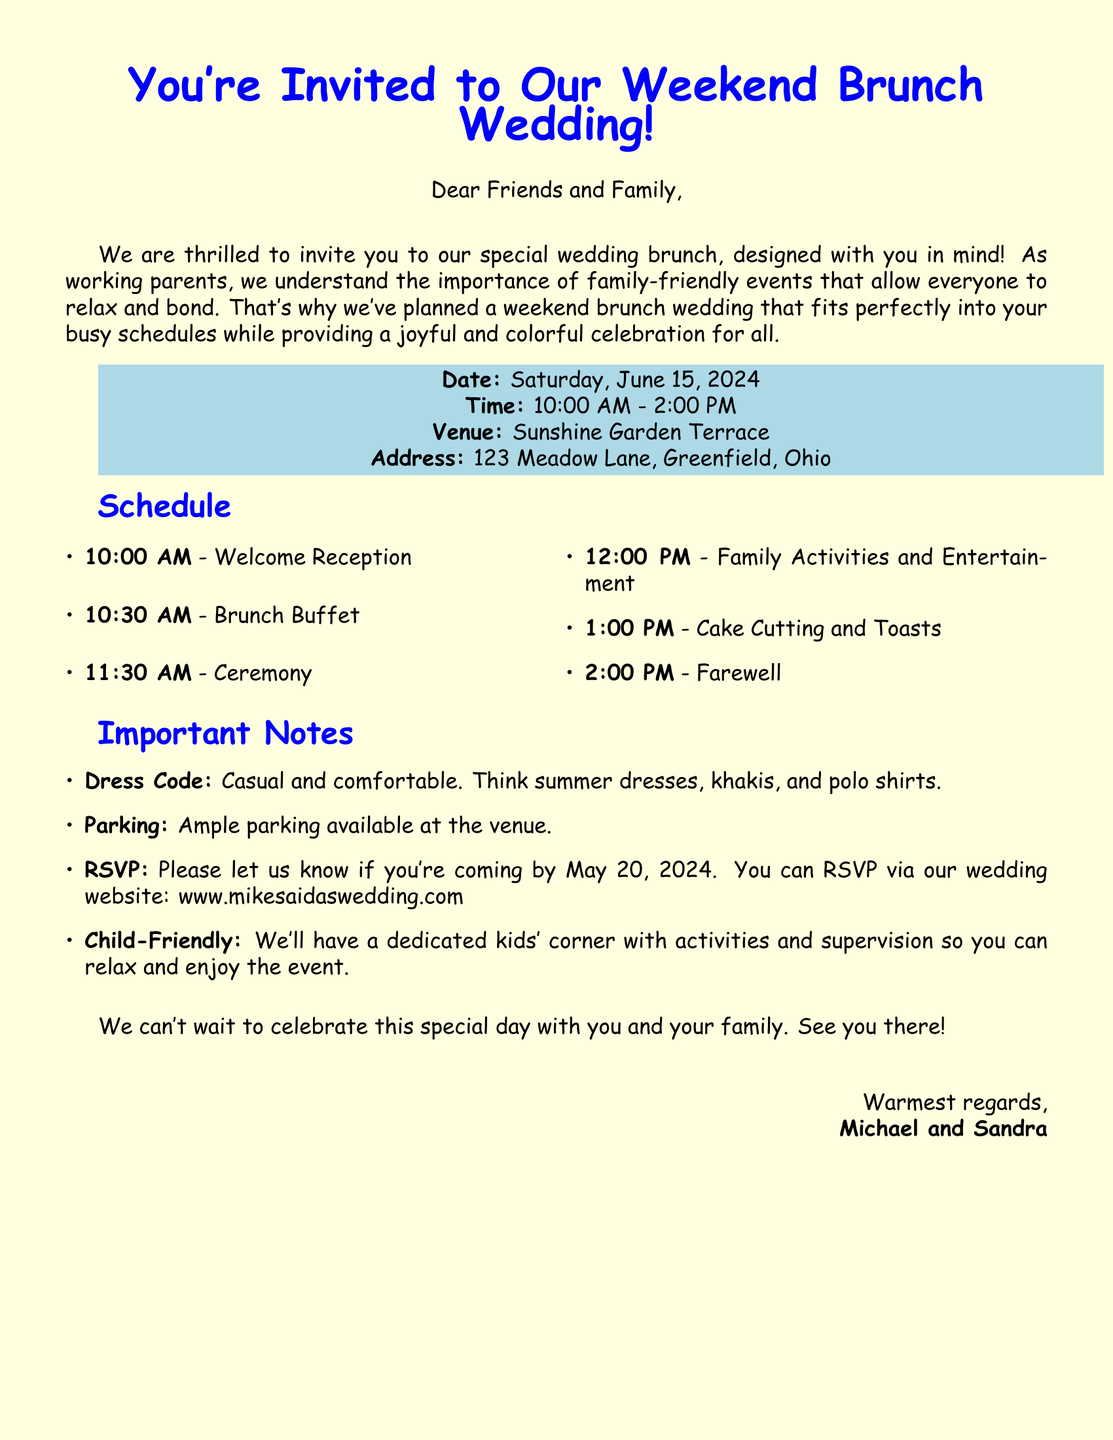What is the date of the wedding brunch? The date of the wedding brunch is explicitly mentioned in the document under the event details.
Answer: Saturday, June 15, 2024 What is the venue for the wedding? The document lists the venue details, providing a clear answer about where the event is held.
Answer: Sunshine Garden Terrace What time does the welcome reception start? The start time for the welcome reception is indicated in the schedule section of the document.
Answer: 10:00 AM What is the dress code for the event? The dress code is specified in the important notes, indicating the attire expected from the guests.
Answer: Casual and comfortable Is there a dedicated area for children? The document mentions arrangements made for child activities, indicating consideration for families with children.
Answer: Yes What is the RSVP deadline? The RSVP deadline is clearly noted in the important notes section, specifying when guests should respond.
Answer: May 20, 2024 What activity follows the brunch buffet? The schedule outlines the order of events, including activities following the brunch.
Answer: Ceremony What type of activities will be available for kids? The document references a kids' corner, hinting at the types of activities planned for children during the event.
Answer: Activities and supervision Who are the hosts of the wedding? The document includes a closing section where the hosts of the event sign off their invitation.
Answer: Michael and Sandra 